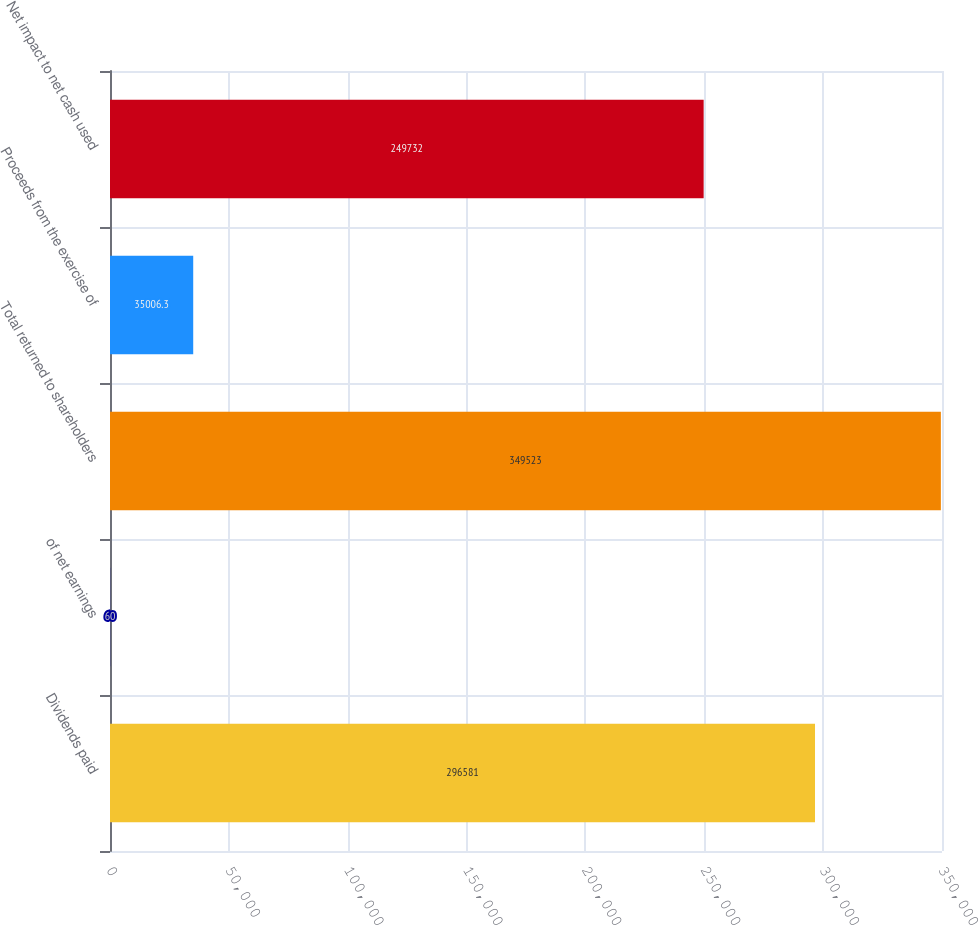Convert chart to OTSL. <chart><loc_0><loc_0><loc_500><loc_500><bar_chart><fcel>Dividends paid<fcel>of net earnings<fcel>Total returned to shareholders<fcel>Proceeds from the exercise of<fcel>Net impact to net cash used<nl><fcel>296581<fcel>60<fcel>349523<fcel>35006.3<fcel>249732<nl></chart> 